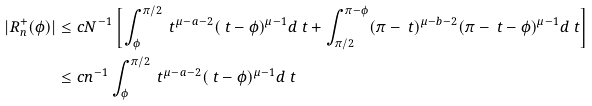<formula> <loc_0><loc_0><loc_500><loc_500>| R _ { n } ^ { + } ( \phi ) | & \leq c N ^ { - 1 } \left [ \int _ { \phi } ^ { \pi / 2 } \ t ^ { \mu - a - 2 } ( \ t - \phi ) ^ { \mu - 1 } d \ t + \int ^ { \pi - \phi } _ { \pi / 2 } ( \pi - \ t ) ^ { \mu - b - 2 } ( \pi - \ t - \phi ) ^ { \mu - 1 } d \ t \right ] \\ & \leq c n ^ { - 1 } \int _ { \phi } ^ { \pi / 2 } \ t ^ { \mu - a - 2 } ( \ t - \phi ) ^ { \mu - 1 } d \ t</formula> 